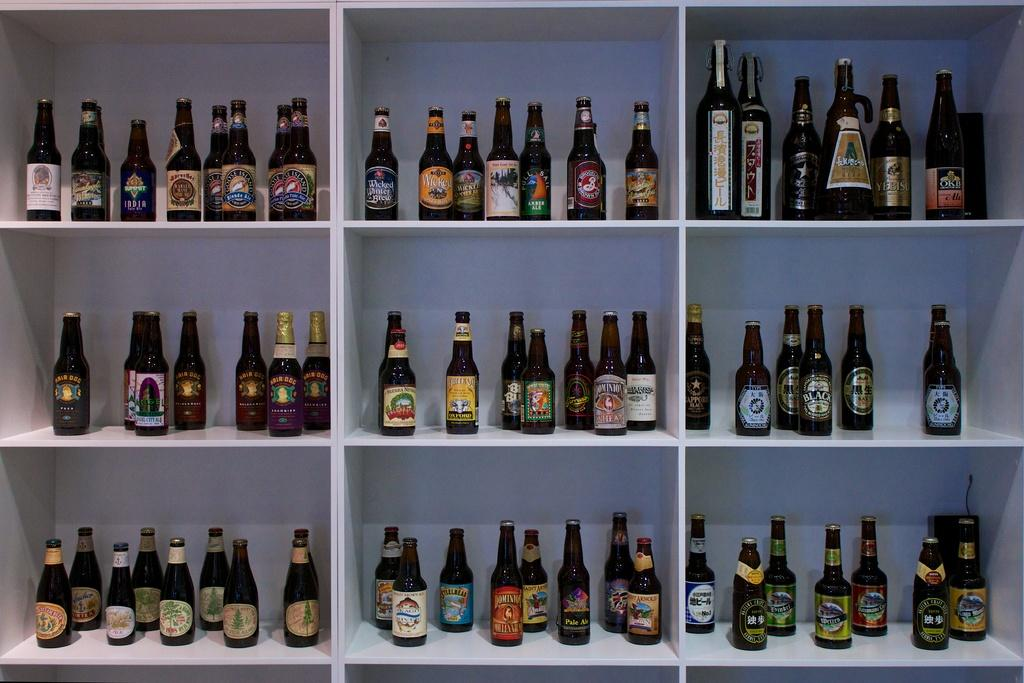What objects can be seen in the image? There are bottles in the image. Where are the bottles located? The bottles are on shelves. How does the pot help the bottles grip the shelves in the image? There is no pot present in the image, and the bottles do not require a pot to grip the shelves. 